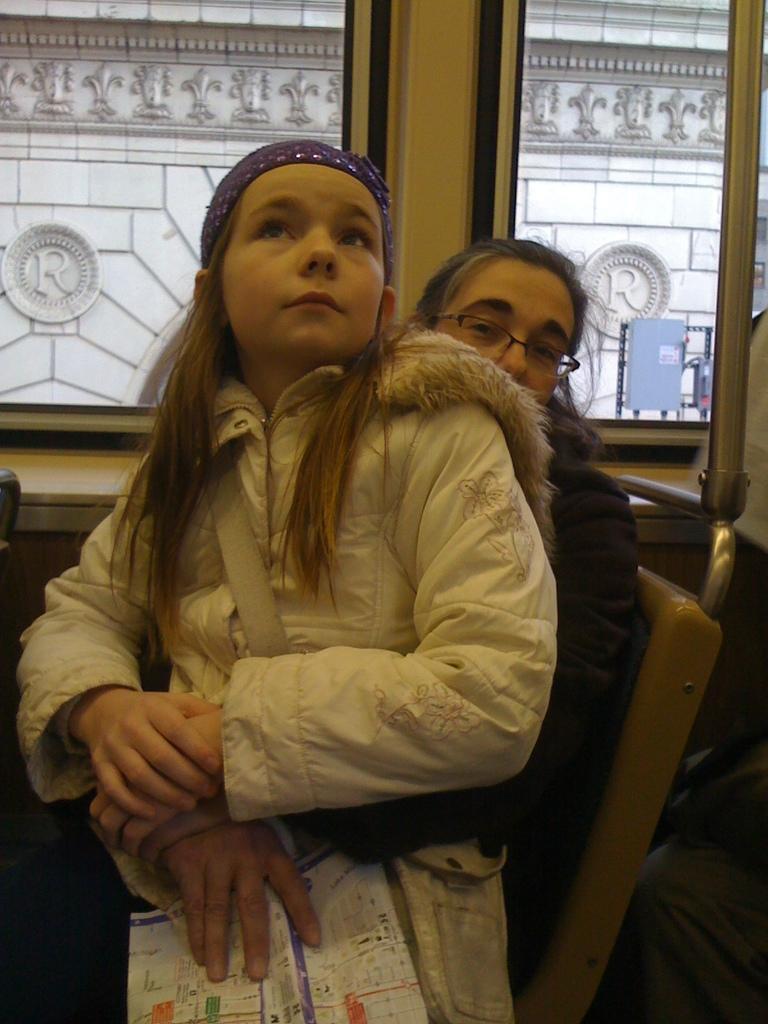In one or two sentences, can you explain what this image depicts? In the image in the center we can see one woman sitting on the bench. And she is holding paper and one kid. In the background there is a table and glass window. Through glass window,we can see one building and sign board. 